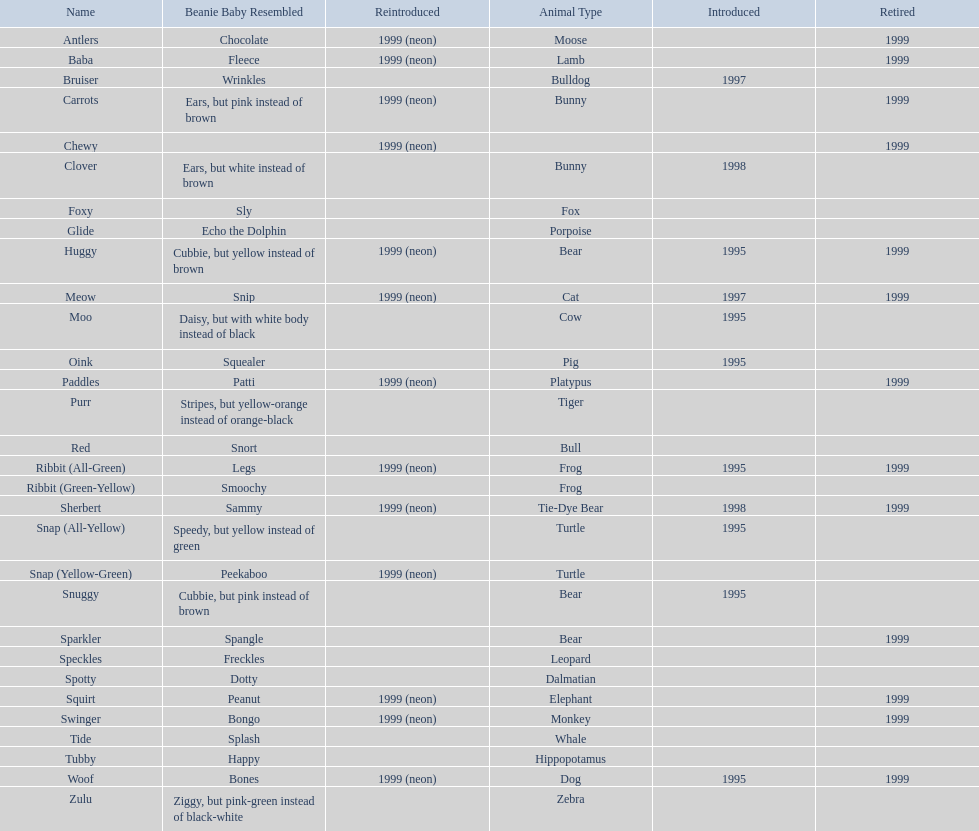What are the names listed? Antlers, Baba, Bruiser, Carrots, Chewy, Clover, Foxy, Glide, Huggy, Meow, Moo, Oink, Paddles, Purr, Red, Ribbit (All-Green), Ribbit (Green-Yellow), Sherbert, Snap (All-Yellow), Snap (Yellow-Green), Snuggy, Sparkler, Speckles, Spotty, Squirt, Swinger, Tide, Tubby, Woof, Zulu. Of these, which is the only pet without an animal type listed? Chewy. 